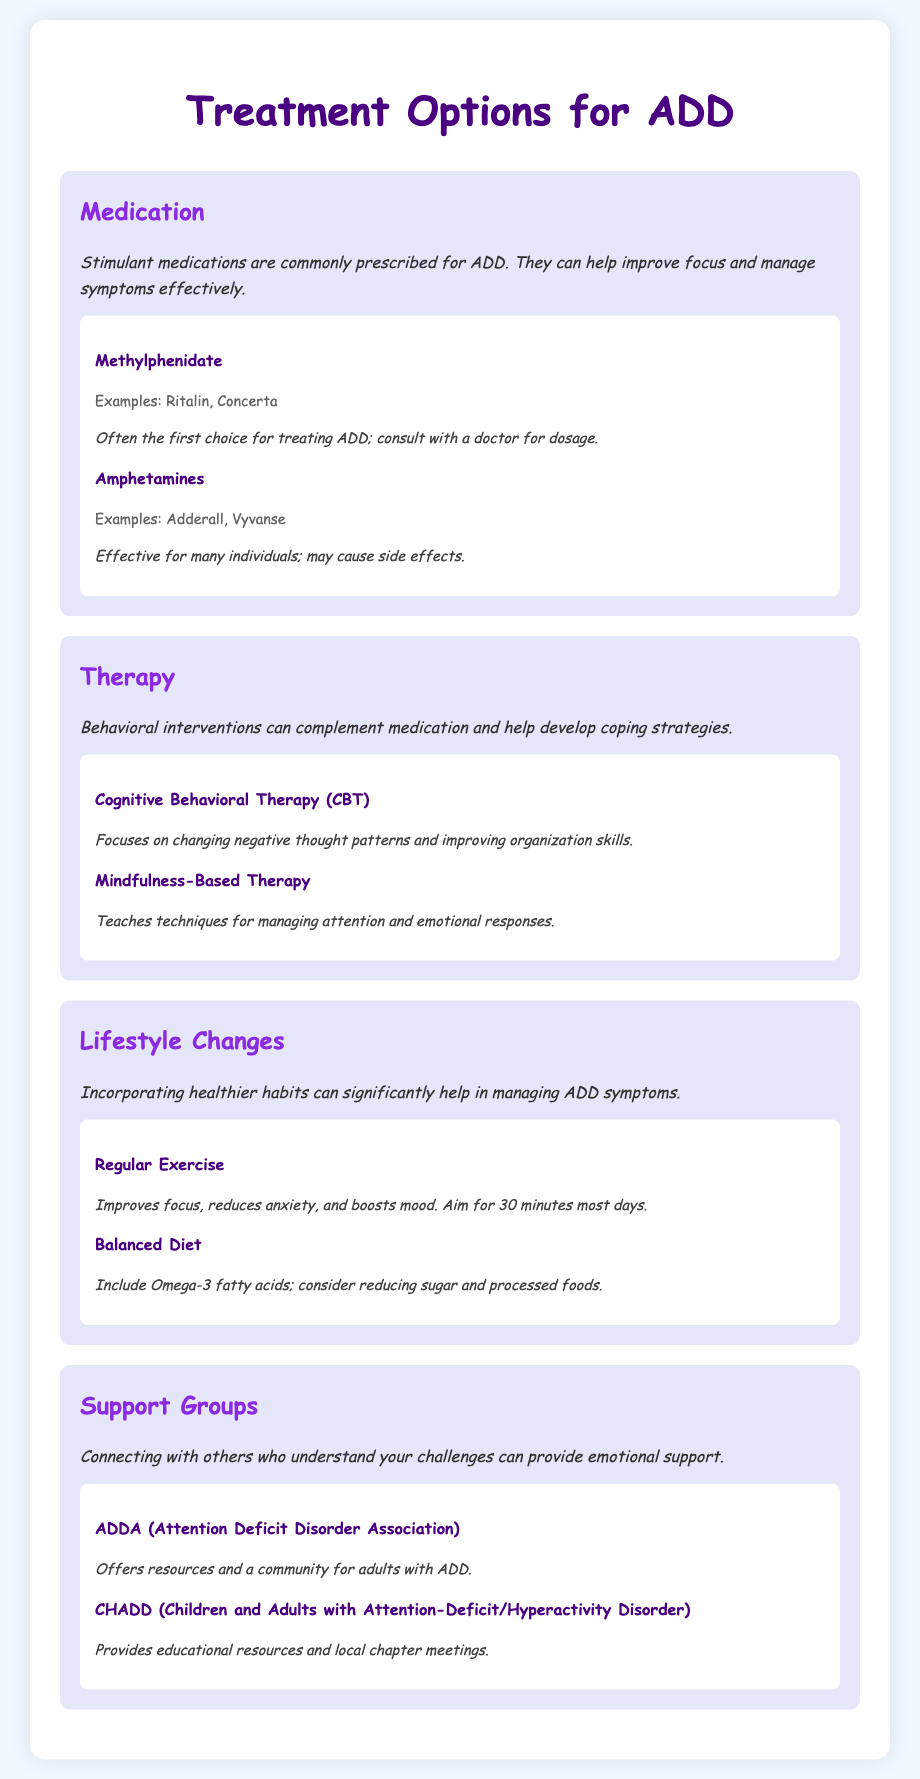What are two examples of Methylphenidate? Methylphenidate is mentioned along with specific examples like Ritalin and Concerta.
Answer: Ritalin, Concerta What type of therapy focuses on changing negative thought patterns? The document lists Cognitive Behavioral Therapy (CBT) as a type of therapy aimed at altering negative thought processes.
Answer: Cognitive Behavioral Therapy (CBT) Name one benefit of Regular Exercise for ADD. The document states that regular exercise improves focus, reduces anxiety, and boosts mood, naming focus as a key benefit.
Answer: Focus What is the first choice for treating ADD mentioned in the medication section? The document indicates that Methylphenidate is often the first choice for treating ADD.
Answer: Methylphenidate Which support group offers resources for adults with ADD? The document provides information about ADDA, which is a support group designed for adults with ADD.
Answer: ADDA How many types of therapy are mentioned in the document? The document lists two therapies, namely Cognitive Behavioral Therapy (CBT) and Mindfulness-Based Therapy.
Answer: Two What is one dietary recommendation for managing ADD symptoms? The document suggests including Omega-3 fatty acids in a balanced diet to help manage ADD symptoms.
Answer: Omega-3 fatty acids Which organization provides educational resources for ADD? The document mentions CHADD, which is known for providing educational resources related to ADD.
Answer: CHADD 